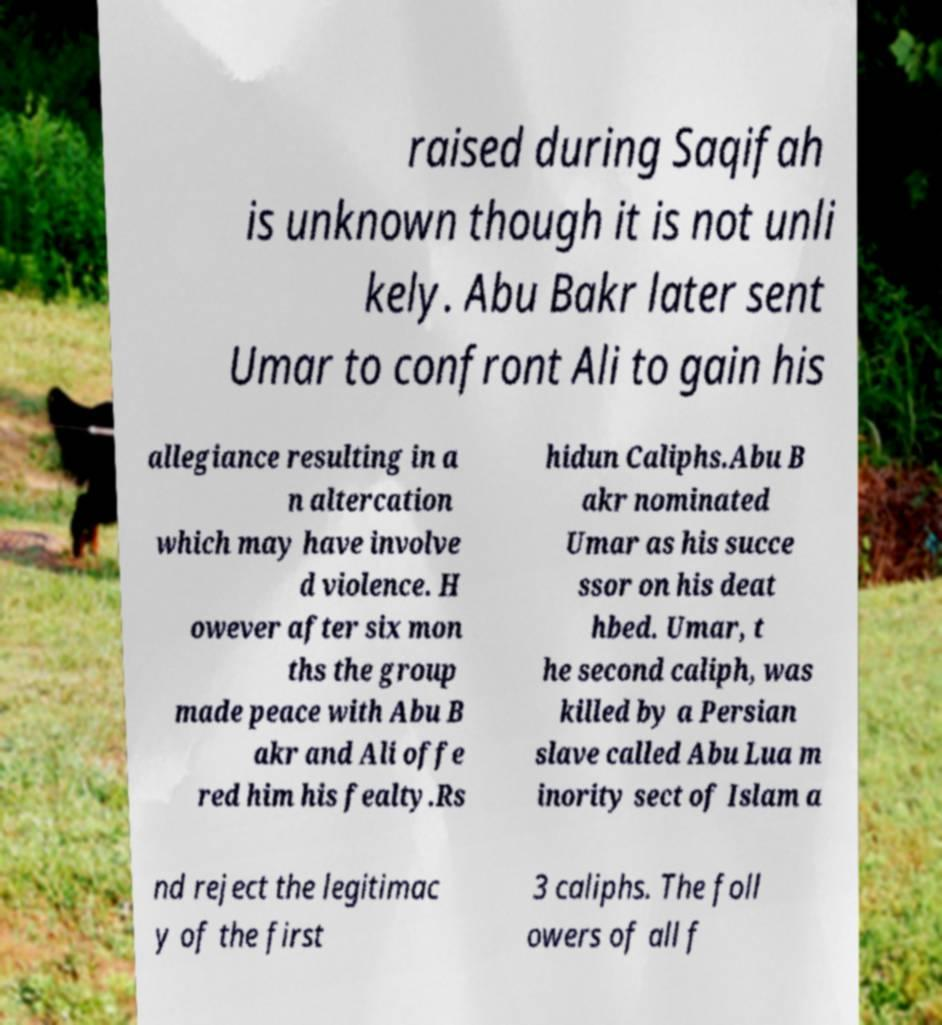Please identify and transcribe the text found in this image. raised during Saqifah is unknown though it is not unli kely. Abu Bakr later sent Umar to confront Ali to gain his allegiance resulting in a n altercation which may have involve d violence. H owever after six mon ths the group made peace with Abu B akr and Ali offe red him his fealty.Rs hidun Caliphs.Abu B akr nominated Umar as his succe ssor on his deat hbed. Umar, t he second caliph, was killed by a Persian slave called Abu Lua m inority sect of Islam a nd reject the legitimac y of the first 3 caliphs. The foll owers of all f 